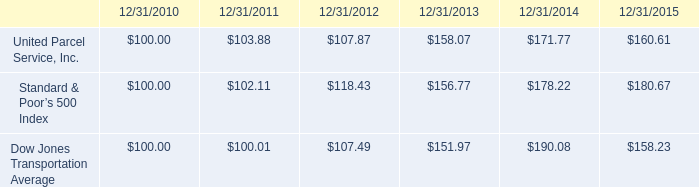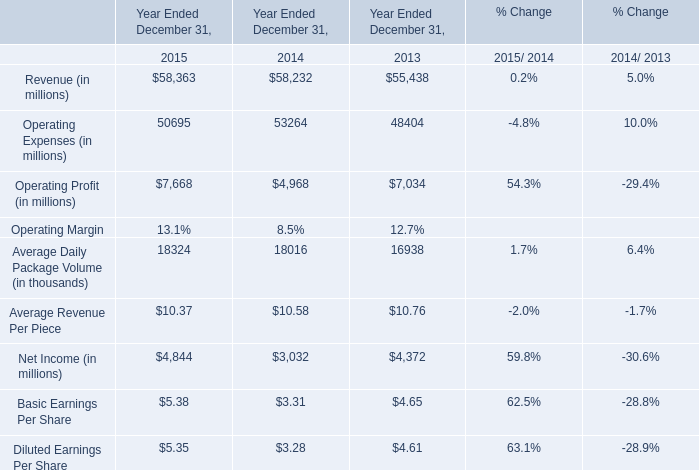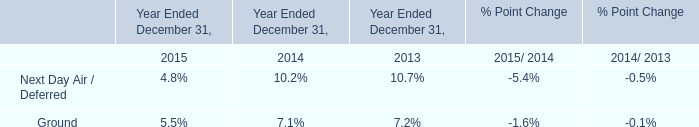what is the five year performance of ups class b common stock? 
Computations: ((160.61 - 100) / 100)
Answer: 0.6061. 